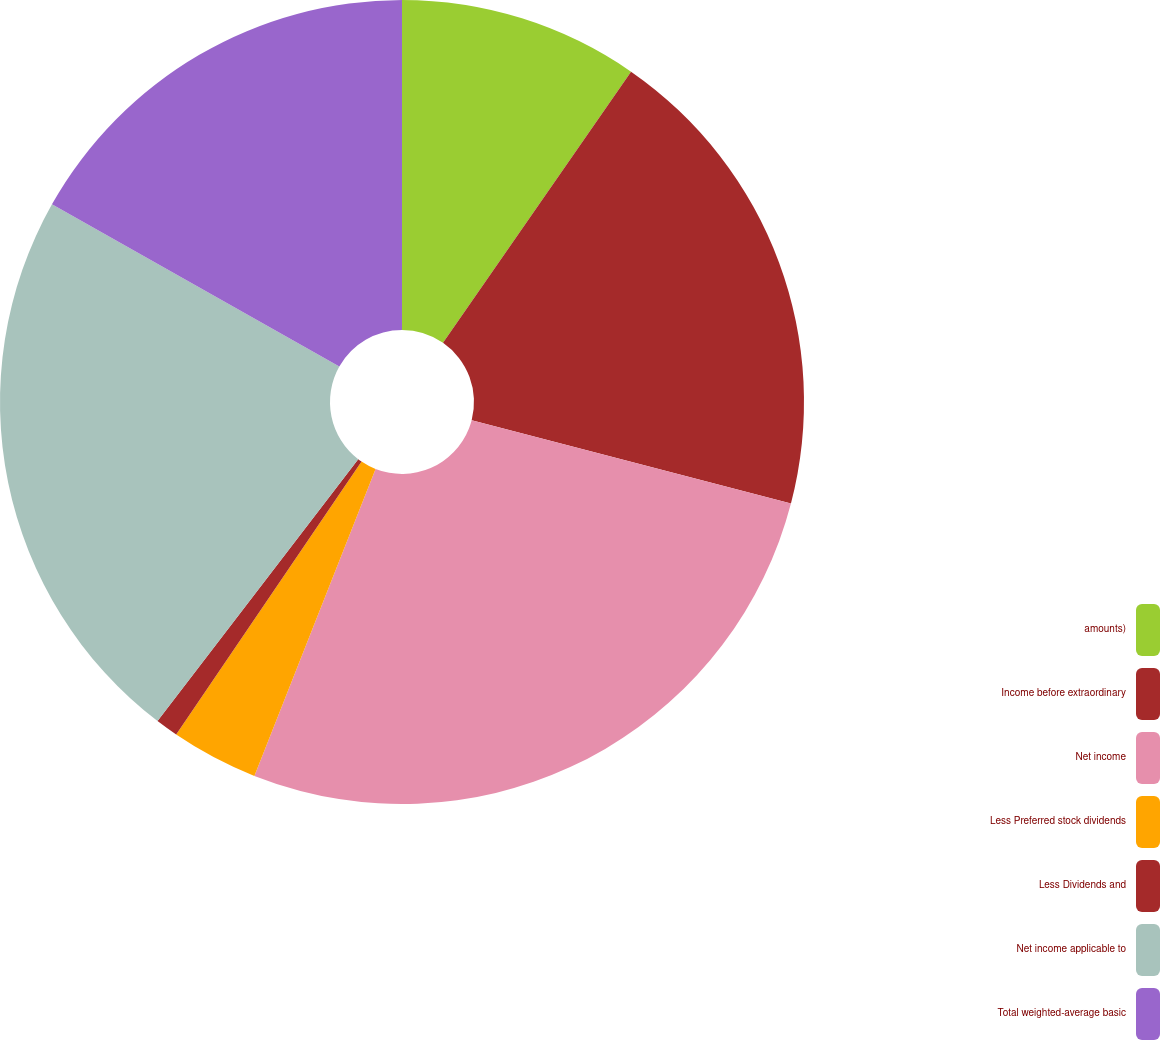Convert chart to OTSL. <chart><loc_0><loc_0><loc_500><loc_500><pie_chart><fcel>amounts)<fcel>Income before extraordinary<fcel>Net income<fcel>Less Preferred stock dividends<fcel>Less Dividends and<fcel>Net income applicable to<fcel>Total weighted-average basic<nl><fcel>9.65%<fcel>19.42%<fcel>26.92%<fcel>3.51%<fcel>0.91%<fcel>22.78%<fcel>16.82%<nl></chart> 